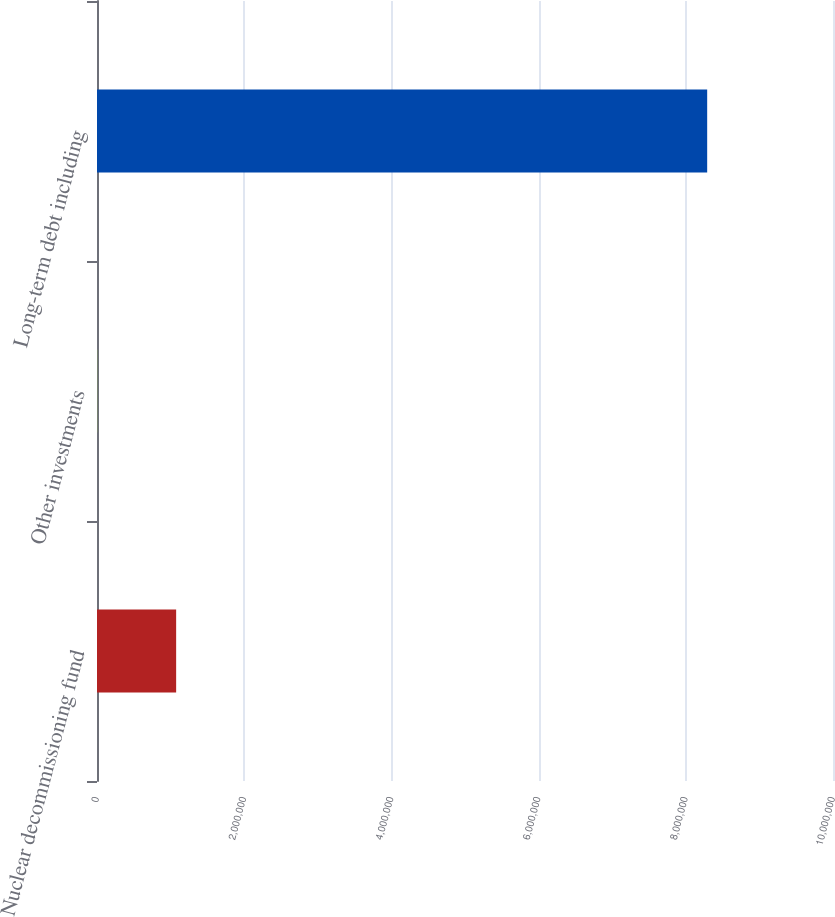Convert chart to OTSL. <chart><loc_0><loc_0><loc_500><loc_500><bar_chart><fcel>Nuclear decommissioning fund<fcel>Other investments<fcel>Long-term debt including<nl><fcel>1.07529e+06<fcel>9864<fcel>8.29046e+06<nl></chart> 